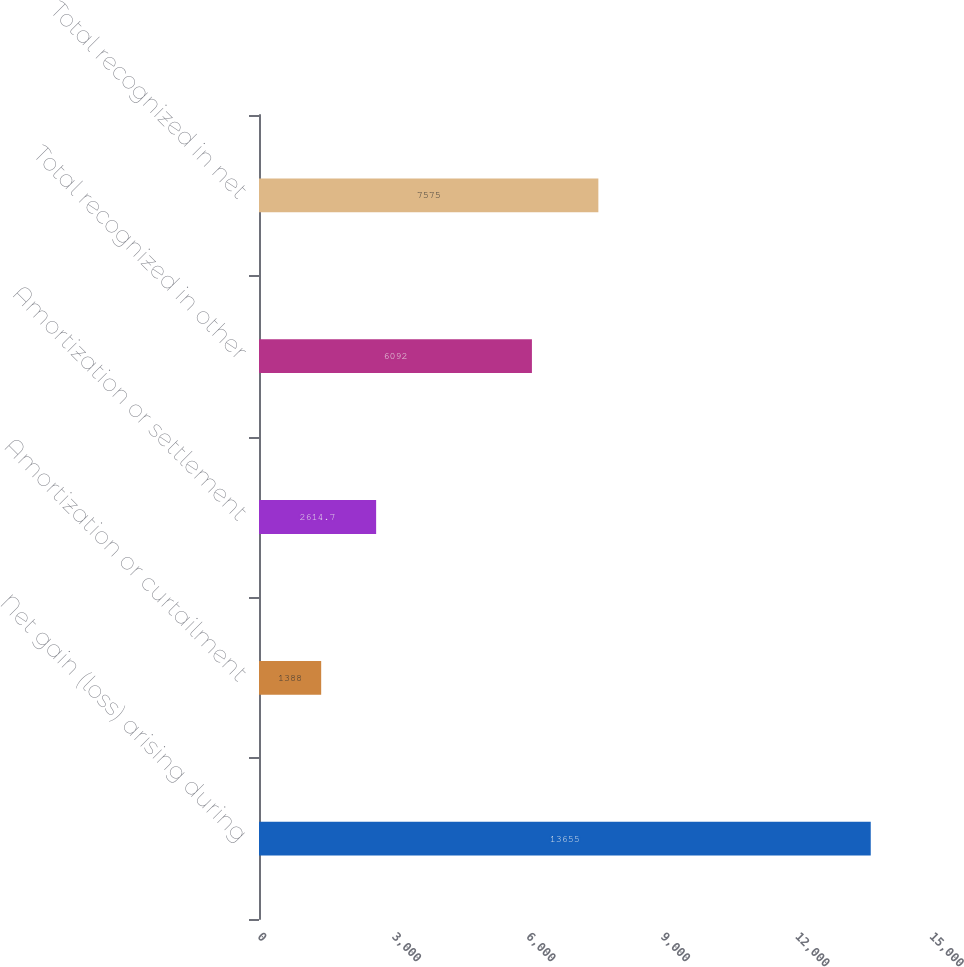Convert chart to OTSL. <chart><loc_0><loc_0><loc_500><loc_500><bar_chart><fcel>Net gain (loss) arising during<fcel>Amortization or curtailment<fcel>Amortization or settlement<fcel>Total recognized in other<fcel>Total recognized in net<nl><fcel>13655<fcel>1388<fcel>2614.7<fcel>6092<fcel>7575<nl></chart> 